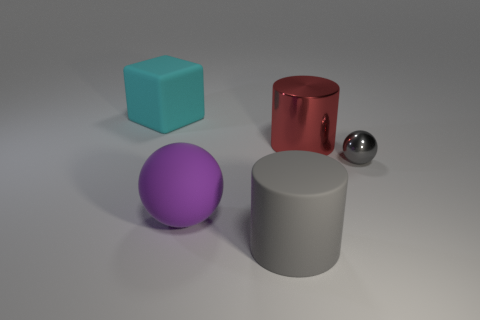Is the material of the gray thing in front of the gray shiny thing the same as the sphere that is on the left side of the large red metallic cylinder? From the image, it appears that both the gray object in front of the reflective surface and the sphere to the left side of the red metallic cylinder have a smooth appearance, indicating that they could be made of the same or at least similar materials. Such materials could include polished metal or plastic with a metallic finish for the gray objects, and the consistency in their shine and reflection quality reinforces this observation. 